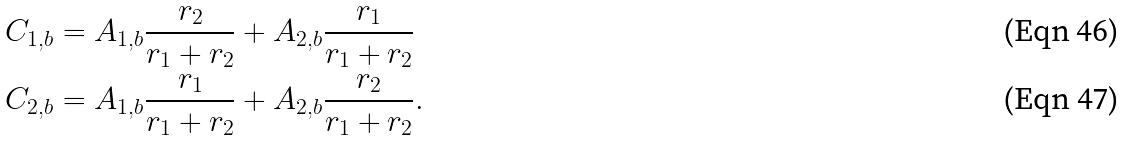Convert formula to latex. <formula><loc_0><loc_0><loc_500><loc_500>& C _ { 1 , b } = A _ { 1 , b } \frac { r _ { 2 } } { r _ { 1 } + r _ { 2 } } + A _ { 2 , b } \frac { r _ { 1 } } { r _ { 1 } + r _ { 2 } } \\ & C _ { 2 , b } = A _ { 1 , b } \frac { r _ { 1 } } { r _ { 1 } + r _ { 2 } } + A _ { 2 , b } \frac { r _ { 2 } } { r _ { 1 } + r _ { 2 } } .</formula> 